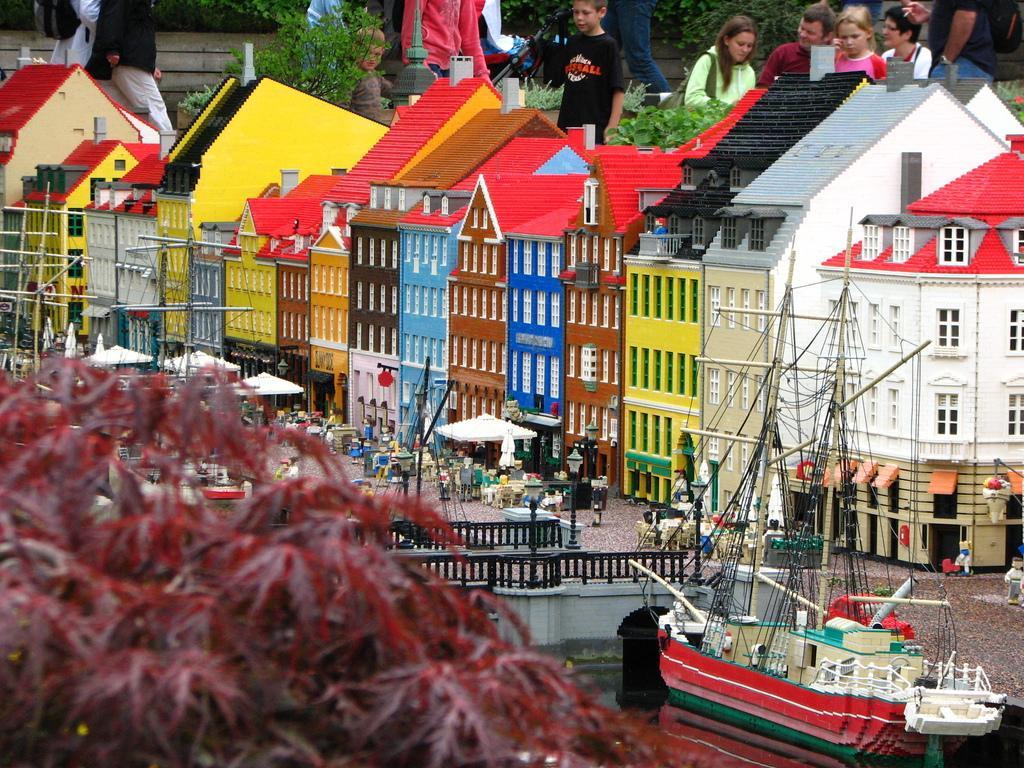Can you describe this image briefly? In this image I can see the miniature of the houses which are colorful. In-front of the buildings I can see the tents and to the right I can see the railing and the ship on the water. In the front I can see the tree which is in red color. In the back I can see few people with different color dresses. I can also see many trees in the back. 